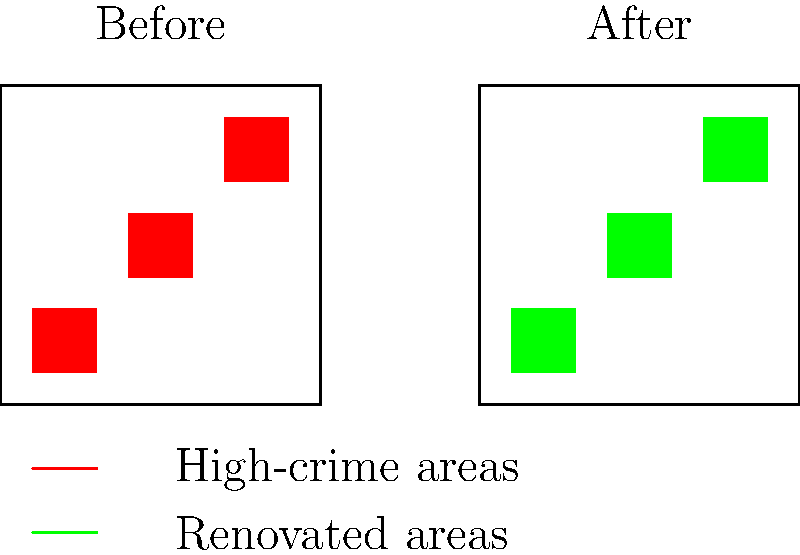Based on the before-and-after city block sketches shown, which of the following statements best describes the potential impact of the urban renewal project on crime rates in this neighborhood?

A) Crime rates will likely increase due to displacement of residents
B) Crime rates will likely decrease due to improved living conditions
C) Crime rates will remain unchanged despite physical improvements
D) Crime rates will shift to adjacent neighborhoods not shown in the sketch To answer this question, we need to analyze the sketches and consider the potential effects of urban renewal on crime rates:

1. The "Before" sketch shows three distinct red areas, representing high-crime zones within the neighborhood.

2. The "After" sketch shows these same areas in green, indicating they have been renovated or improved through urban renewal efforts.

3. Urban renewal projects typically aim to:
   a) Improve physical infrastructure and living conditions
   b) Increase property values and attract new investments
   c) Enhance community spaces and recreational facilities
   d) Promote social cohesion and community engagement

4. These improvements can potentially reduce crime rates through:
   a) Increased natural surveillance (e.g., better lighting, more foot traffic)
   b) Improved economic opportunities for residents
   c) Enhanced sense of community and social control
   d) Reduced physical deterioration that may attract criminal activity

5. The "broken windows" theory suggests that visible signs of disorder and neglect can lead to increased criminal activity. By addressing these issues, urban renewal may help reduce crime.

6. However, it's important to note that urban renewal alone is not a guaranteed solution to crime. Other factors, such as social programs, community policing, and addressing root causes of crime, are also crucial.

7. While displacement of residents is a concern in some urban renewal projects, the question doesn't provide information about this aspect, so we cannot assume it will lead to increased crime rates.

Considering these factors, the most likely outcome based on the information provided is that crime rates will decrease due to improved living conditions and the associated benefits of urban renewal.
Answer: B) Crime rates will likely decrease due to improved living conditions 